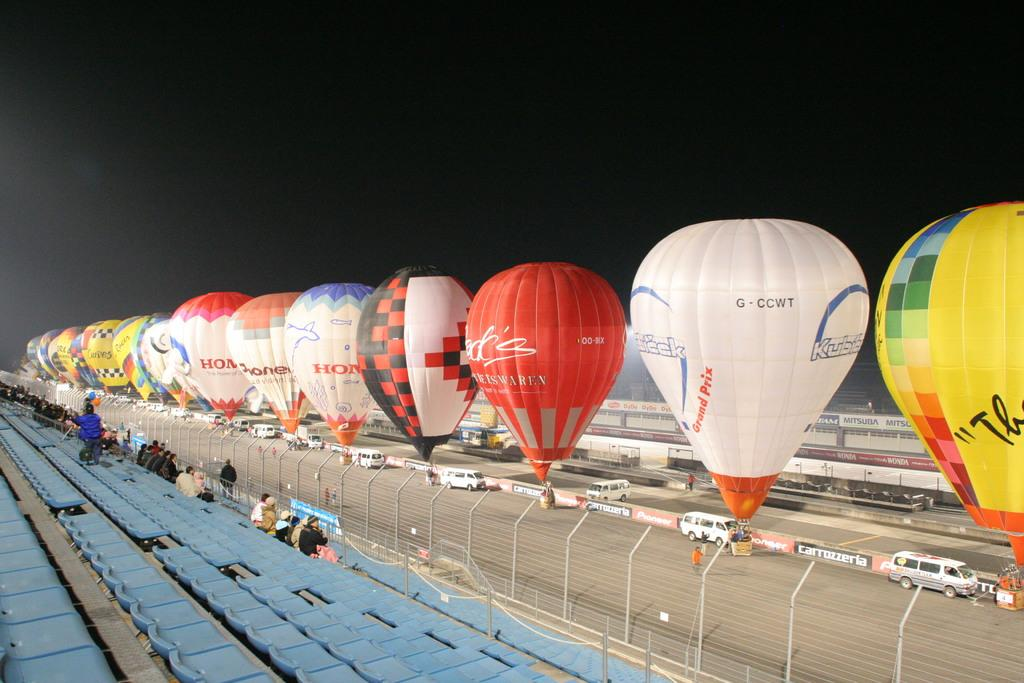What type of furniture is present in the image? There are chairs in the image. Who or what is present in the image? There are people in the image. What equipment is visible in the image? There are parachutes in the image. What type of structures can be seen in the image? There are buildings in the image. What part of the natural environment is visible in the image? The sky is visible in the image. What type of hammer is being used by the person in the image? There is no hammer present in the image. How many bulbs are visible in the image? There are no bulbs visible in the image. 